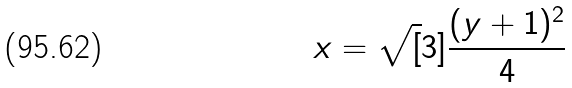<formula> <loc_0><loc_0><loc_500><loc_500>x = \sqrt { [ } 3 ] { \frac { ( y + 1 ) ^ { 2 } } { 4 } }</formula> 